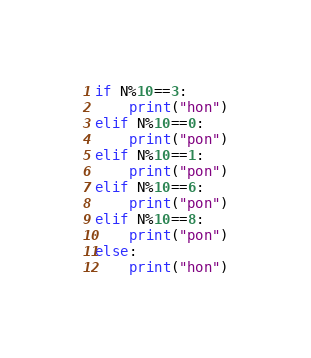<code> <loc_0><loc_0><loc_500><loc_500><_Python_>if N%10==3:
    print("hon")
elif N%10==0:
    print("pon")
elif N%10==1:
    print("pon")
elif N%10==6:
    print("pon")
elif N%10==8:
    print("pon")
else:
    print("hon")</code> 